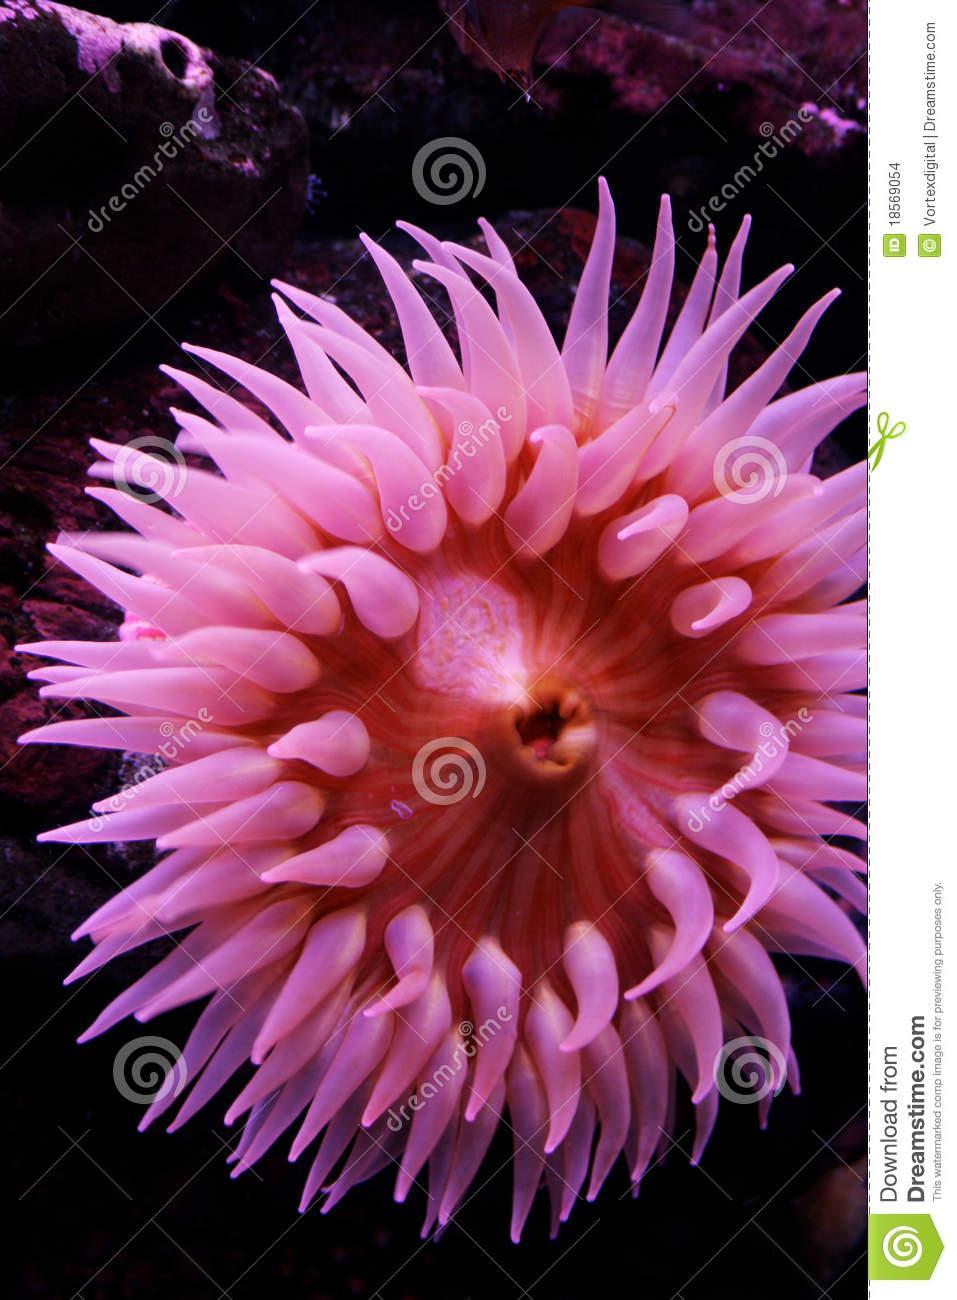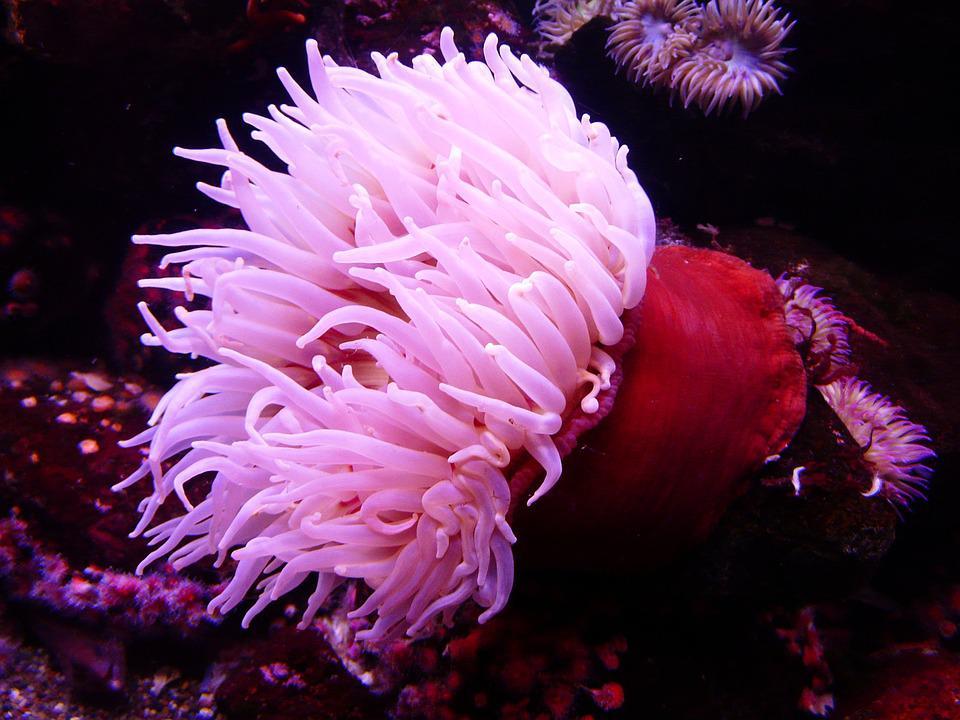The first image is the image on the left, the second image is the image on the right. Considering the images on both sides, is "The trunk of the anemone can be seen in the image on the left." valid? Answer yes or no. No. The first image is the image on the left, the second image is the image on the right. Evaluate the accuracy of this statement regarding the images: "The left image shows a white anemone with its mouth-like center visible.". Is it true? Answer yes or no. No. 